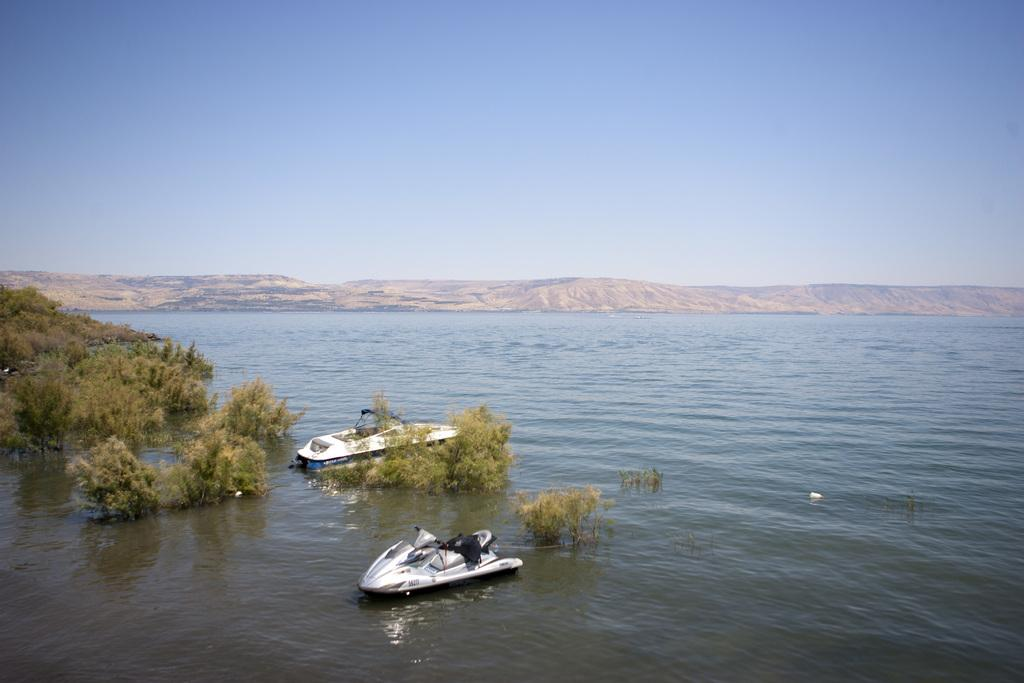How many boats can be seen in the water in the image? There are two boats in the water in the image. What type of natural environment is visible in the image? Trees and mountains are visible in the image, along with water. What is visible in the background of the image? The sky is visible in the background of the image. What color is the crayon being used to draw the boats in the image? There is no crayon present in the image; it is a photograph or illustration of the boats in the water. Can you tell me how many people are on the boats in the image? There is no indication of people on the boats in the image, so it cannot be determined from the picture. 